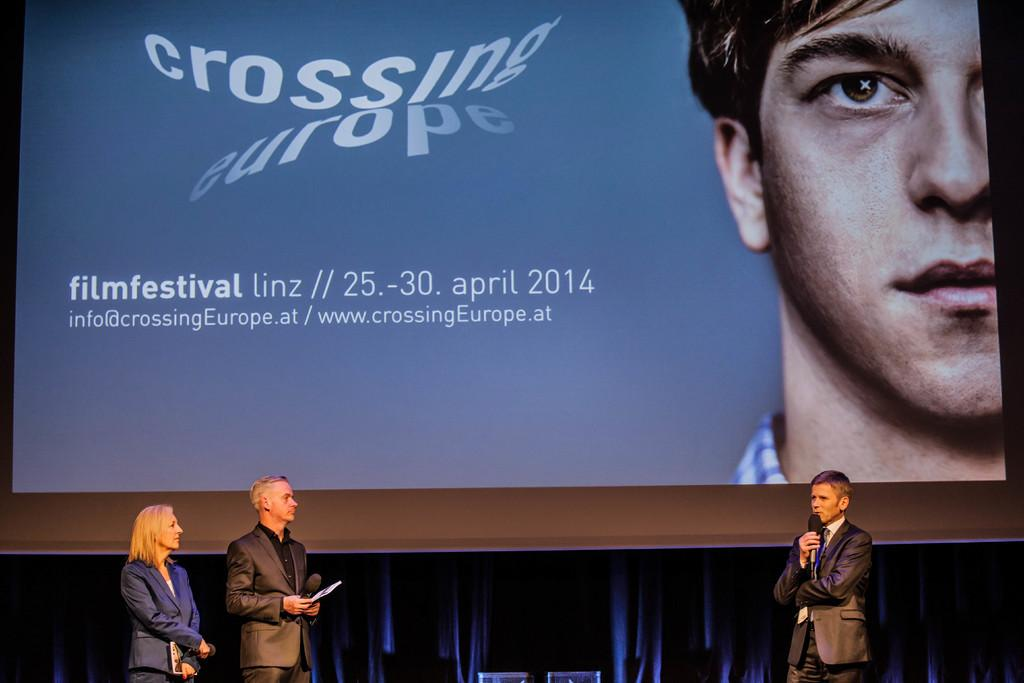How many people are in the image? There are three persons standing in the image. What are the persons holding in their hands? The persons are holding microphones. What can be seen in the background of the image? There is a screen in the background of the image. What is displayed on the screen? Text is visible on the screen, and there is a person visible on the screen. What type of eggnog is being prepared on the stove in the image? There is no stove or eggnog present in the image. Can you describe the locket that the person on the screen is wearing? There is no locket visible on the person in the image. 